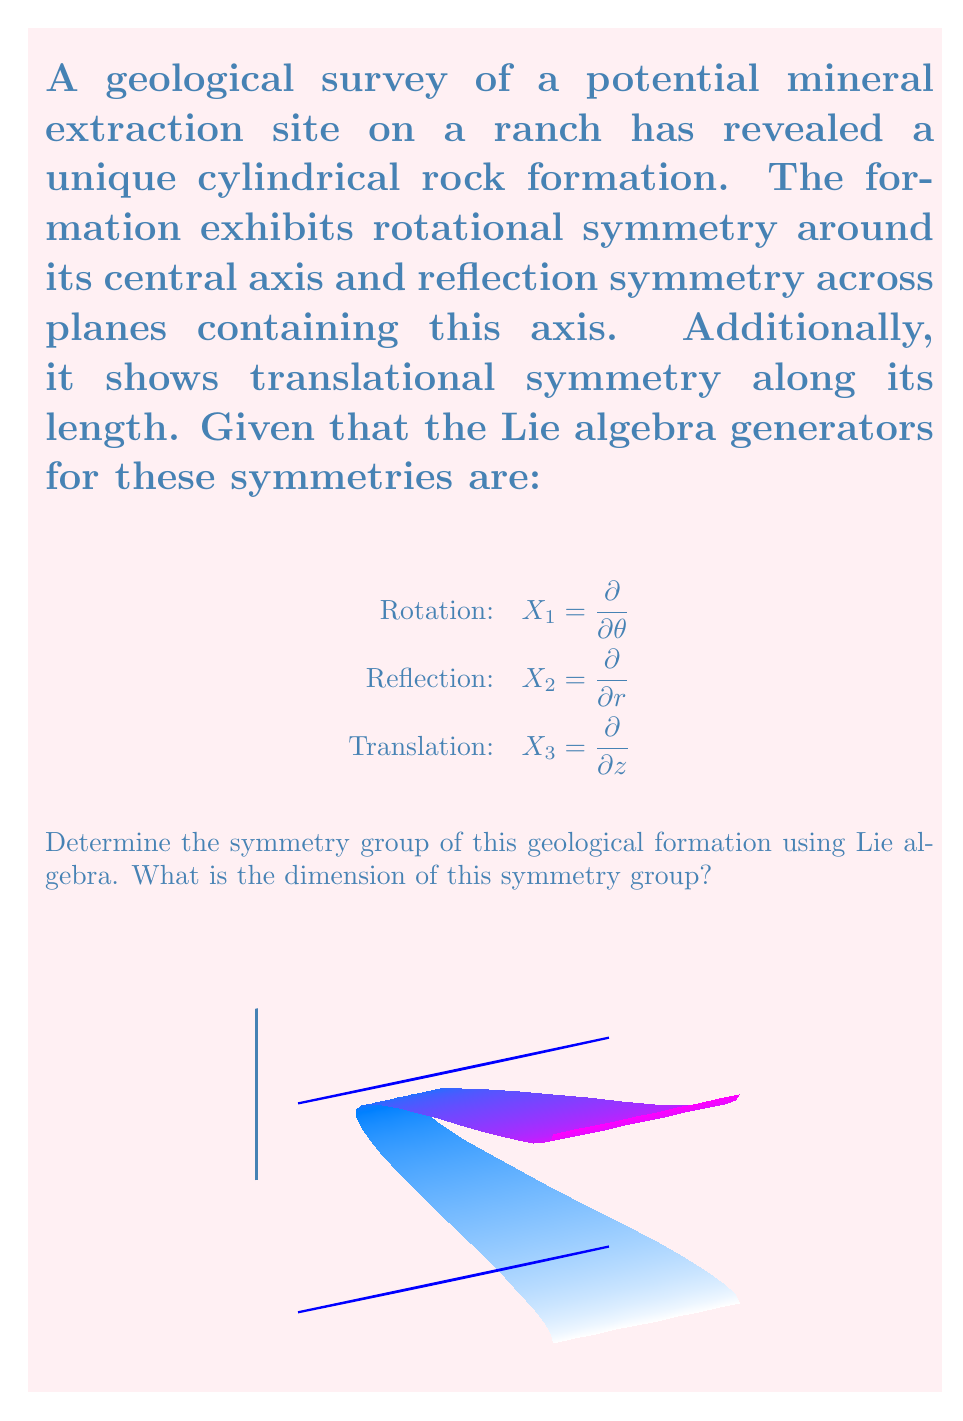Can you solve this math problem? To determine the symmetry group and its dimension using Lie algebra, we need to follow these steps:

1) First, we identify the Lie algebra generators given:
   $X_1 = \frac{\partial}{\partial \theta}$ (rotation)
   $X_2 = \frac{\partial}{\partial r}$ (reflection)
   $X_3 = \frac{\partial}{\partial z}$ (translation)

2) We need to check if these generators form a closed Lie algebra by computing their commutators:

   $[X_1, X_2] = [\frac{\partial}{\partial \theta}, \frac{\partial}{\partial r}] = 0$
   $[X_1, X_3] = [\frac{\partial}{\partial \theta}, \frac{\partial}{\partial z}] = 0$
   $[X_2, X_3] = [\frac{\partial}{\partial r}, \frac{\partial}{\partial z}] = 0$

3) All commutators vanish, which means these generators commute with each other. This indicates that the Lie algebra is abelian.

4) The number of linearly independent generators determines the dimension of the Lie algebra and, consequently, the dimension of the symmetry group. Here, we have three independent generators.

5) The symmetry transformations generated by these operators are:
   - Rotations around the z-axis (SO(2) or U(1))
   - Reflections in the r-direction (Z_2)
   - Translations along the z-axis (R)

6) The overall symmetry group is the direct product of these individual symmetry groups:
   SO(2) × Z_2 × R

7) The dimension of this group is the sum of the dimensions of its components:
   dim(SO(2)) + dim(Z_2) + dim(R) = 1 + 0 + 1 = 2

Therefore, the symmetry group of the geological formation is 2-dimensional.
Answer: SO(2) × Z_2 × R, dimension 2 